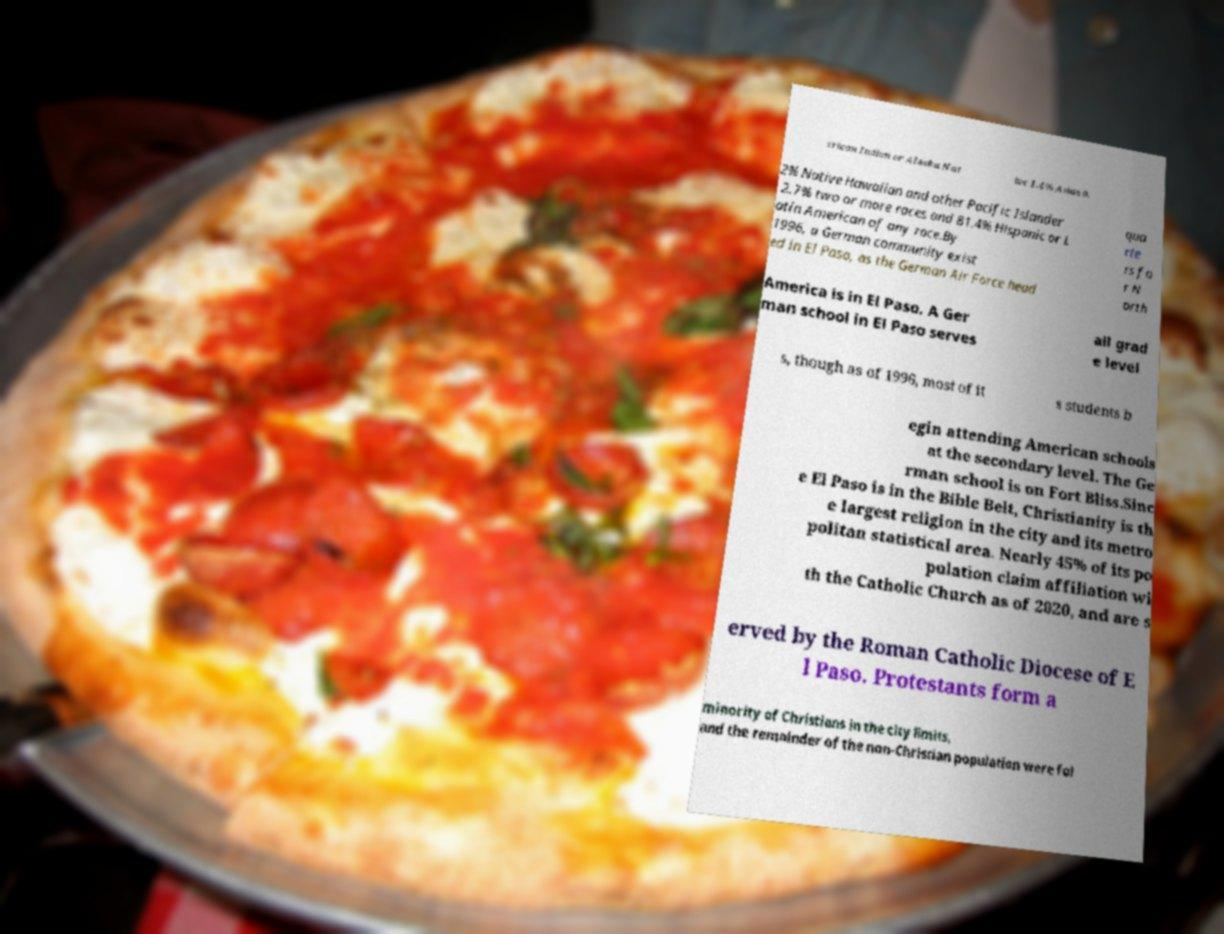Could you extract and type out the text from this image? erican Indian or Alaska Nat ive 1.4% Asian 0. 2% Native Hawaiian and other Pacific Islander 2.7% two or more races and 81.4% Hispanic or L atin American of any race.By 1996, a German community exist ed in El Paso, as the German Air Force head qua rte rs fo r N orth America is in El Paso. A Ger man school in El Paso serves all grad e level s, though as of 1996, most of it s students b egin attending American schools at the secondary level. The Ge rman school is on Fort Bliss.Sinc e El Paso is in the Bible Belt, Christianity is th e largest religion in the city and its metro politan statistical area. Nearly 45% of its po pulation claim affiliation wi th the Catholic Church as of 2020, and are s erved by the Roman Catholic Diocese of E l Paso. Protestants form a minority of Christians in the city limits, and the remainder of the non-Christian population were fol 